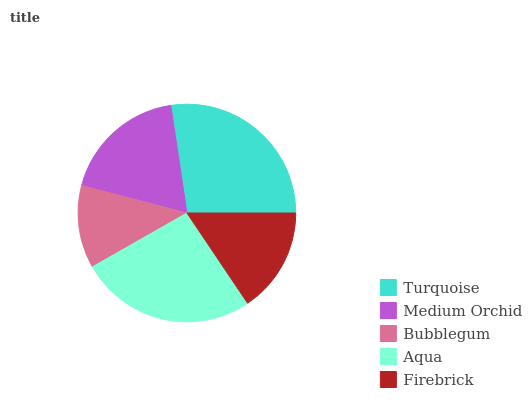Is Bubblegum the minimum?
Answer yes or no. Yes. Is Turquoise the maximum?
Answer yes or no. Yes. Is Medium Orchid the minimum?
Answer yes or no. No. Is Medium Orchid the maximum?
Answer yes or no. No. Is Turquoise greater than Medium Orchid?
Answer yes or no. Yes. Is Medium Orchid less than Turquoise?
Answer yes or no. Yes. Is Medium Orchid greater than Turquoise?
Answer yes or no. No. Is Turquoise less than Medium Orchid?
Answer yes or no. No. Is Medium Orchid the high median?
Answer yes or no. Yes. Is Medium Orchid the low median?
Answer yes or no. Yes. Is Bubblegum the high median?
Answer yes or no. No. Is Aqua the low median?
Answer yes or no. No. 